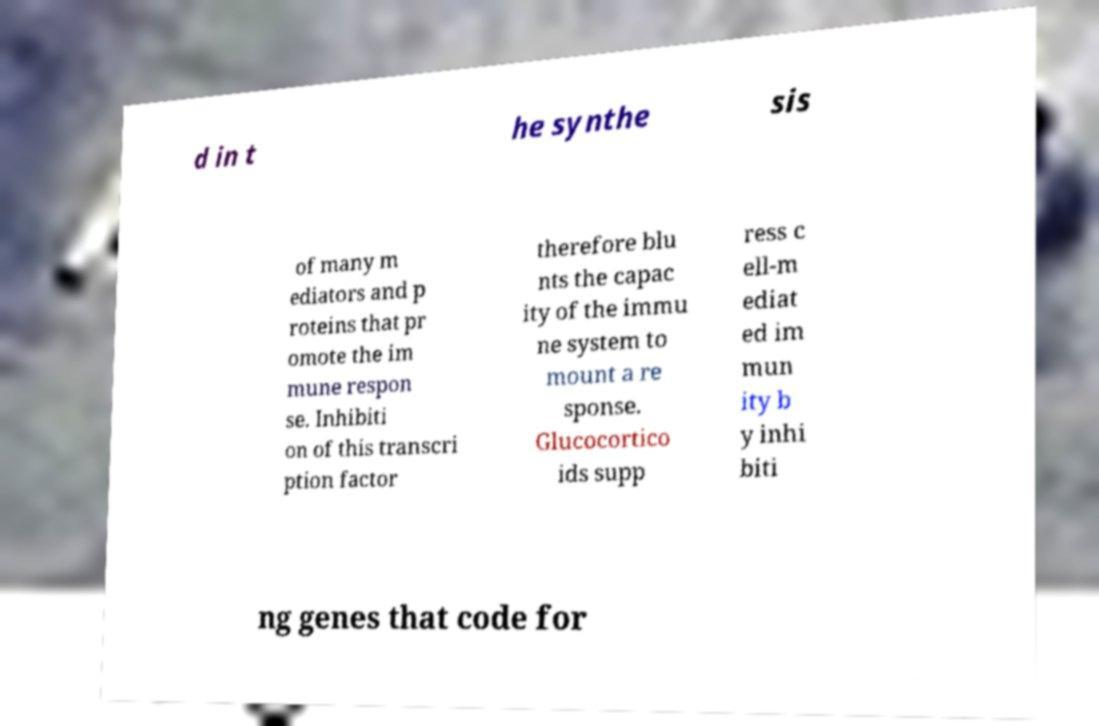What messages or text are displayed in this image? I need them in a readable, typed format. d in t he synthe sis of many m ediators and p roteins that pr omote the im mune respon se. Inhibiti on of this transcri ption factor therefore blu nts the capac ity of the immu ne system to mount a re sponse. Glucocortico ids supp ress c ell-m ediat ed im mun ity b y inhi biti ng genes that code for 